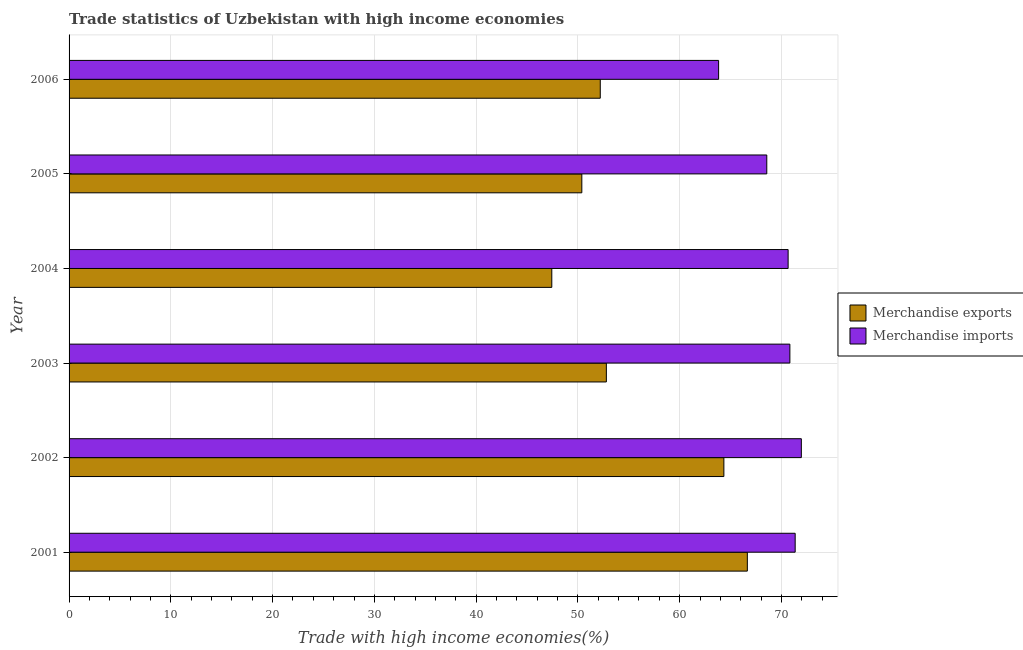Are the number of bars on each tick of the Y-axis equal?
Offer a terse response. Yes. How many bars are there on the 4th tick from the top?
Your answer should be very brief. 2. What is the label of the 1st group of bars from the top?
Your response must be concise. 2006. In how many cases, is the number of bars for a given year not equal to the number of legend labels?
Provide a succinct answer. 0. What is the merchandise exports in 2001?
Keep it short and to the point. 66.65. Across all years, what is the maximum merchandise imports?
Your answer should be very brief. 71.96. Across all years, what is the minimum merchandise exports?
Provide a short and direct response. 47.44. In which year was the merchandise exports minimum?
Your response must be concise. 2004. What is the total merchandise imports in the graph?
Give a very brief answer. 417.2. What is the difference between the merchandise imports in 2004 and that in 2006?
Your answer should be very brief. 6.83. What is the difference between the merchandise imports in 2002 and the merchandise exports in 2004?
Provide a short and direct response. 24.52. What is the average merchandise imports per year?
Ensure brevity in your answer.  69.53. In the year 2006, what is the difference between the merchandise imports and merchandise exports?
Your answer should be compact. 11.63. In how many years, is the merchandise imports greater than 72 %?
Give a very brief answer. 0. What is the ratio of the merchandise imports in 2002 to that in 2004?
Ensure brevity in your answer.  1.02. Is the difference between the merchandise imports in 2005 and 2006 greater than the difference between the merchandise exports in 2005 and 2006?
Your answer should be very brief. Yes. What is the difference between the highest and the second highest merchandise imports?
Make the answer very short. 0.61. What is the difference between the highest and the lowest merchandise imports?
Offer a terse response. 8.13. In how many years, is the merchandise exports greater than the average merchandise exports taken over all years?
Your response must be concise. 2. Is the sum of the merchandise imports in 2002 and 2005 greater than the maximum merchandise exports across all years?
Offer a very short reply. Yes. What does the 1st bar from the top in 2002 represents?
Offer a terse response. Merchandise imports. What does the 1st bar from the bottom in 2004 represents?
Your answer should be very brief. Merchandise exports. Are all the bars in the graph horizontal?
Give a very brief answer. Yes. What is the difference between two consecutive major ticks on the X-axis?
Provide a short and direct response. 10. Does the graph contain any zero values?
Your response must be concise. No. Does the graph contain grids?
Provide a short and direct response. Yes. How are the legend labels stacked?
Your answer should be very brief. Vertical. What is the title of the graph?
Offer a very short reply. Trade statistics of Uzbekistan with high income economies. Does "Constant 2005 US$" appear as one of the legend labels in the graph?
Provide a short and direct response. No. What is the label or title of the X-axis?
Provide a short and direct response. Trade with high income economies(%). What is the Trade with high income economies(%) of Merchandise exports in 2001?
Your response must be concise. 66.65. What is the Trade with high income economies(%) in Merchandise imports in 2001?
Keep it short and to the point. 71.35. What is the Trade with high income economies(%) in Merchandise exports in 2002?
Offer a very short reply. 64.35. What is the Trade with high income economies(%) in Merchandise imports in 2002?
Give a very brief answer. 71.96. What is the Trade with high income economies(%) in Merchandise exports in 2003?
Your answer should be very brief. 52.8. What is the Trade with high income economies(%) of Merchandise imports in 2003?
Provide a succinct answer. 70.83. What is the Trade with high income economies(%) in Merchandise exports in 2004?
Offer a very short reply. 47.44. What is the Trade with high income economies(%) of Merchandise imports in 2004?
Ensure brevity in your answer.  70.66. What is the Trade with high income economies(%) in Merchandise exports in 2005?
Offer a terse response. 50.39. What is the Trade with high income economies(%) in Merchandise imports in 2005?
Give a very brief answer. 68.56. What is the Trade with high income economies(%) of Merchandise exports in 2006?
Provide a succinct answer. 52.2. What is the Trade with high income economies(%) in Merchandise imports in 2006?
Ensure brevity in your answer.  63.83. Across all years, what is the maximum Trade with high income economies(%) of Merchandise exports?
Your answer should be very brief. 66.65. Across all years, what is the maximum Trade with high income economies(%) in Merchandise imports?
Your answer should be compact. 71.96. Across all years, what is the minimum Trade with high income economies(%) of Merchandise exports?
Your answer should be very brief. 47.44. Across all years, what is the minimum Trade with high income economies(%) in Merchandise imports?
Your response must be concise. 63.83. What is the total Trade with high income economies(%) of Merchandise exports in the graph?
Offer a terse response. 333.82. What is the total Trade with high income economies(%) in Merchandise imports in the graph?
Ensure brevity in your answer.  417.2. What is the difference between the Trade with high income economies(%) in Merchandise exports in 2001 and that in 2002?
Your answer should be compact. 2.31. What is the difference between the Trade with high income economies(%) of Merchandise imports in 2001 and that in 2002?
Make the answer very short. -0.61. What is the difference between the Trade with high income economies(%) of Merchandise exports in 2001 and that in 2003?
Your answer should be compact. 13.85. What is the difference between the Trade with high income economies(%) in Merchandise imports in 2001 and that in 2003?
Your answer should be very brief. 0.52. What is the difference between the Trade with high income economies(%) of Merchandise exports in 2001 and that in 2004?
Your answer should be compact. 19.22. What is the difference between the Trade with high income economies(%) of Merchandise imports in 2001 and that in 2004?
Ensure brevity in your answer.  0.69. What is the difference between the Trade with high income economies(%) in Merchandise exports in 2001 and that in 2005?
Your answer should be very brief. 16.27. What is the difference between the Trade with high income economies(%) in Merchandise imports in 2001 and that in 2005?
Keep it short and to the point. 2.79. What is the difference between the Trade with high income economies(%) of Merchandise exports in 2001 and that in 2006?
Your answer should be compact. 14.45. What is the difference between the Trade with high income economies(%) in Merchandise imports in 2001 and that in 2006?
Offer a very short reply. 7.52. What is the difference between the Trade with high income economies(%) of Merchandise exports in 2002 and that in 2003?
Keep it short and to the point. 11.55. What is the difference between the Trade with high income economies(%) in Merchandise imports in 2002 and that in 2003?
Keep it short and to the point. 1.13. What is the difference between the Trade with high income economies(%) in Merchandise exports in 2002 and that in 2004?
Provide a short and direct response. 16.91. What is the difference between the Trade with high income economies(%) in Merchandise imports in 2002 and that in 2004?
Provide a succinct answer. 1.3. What is the difference between the Trade with high income economies(%) of Merchandise exports in 2002 and that in 2005?
Offer a very short reply. 13.96. What is the difference between the Trade with high income economies(%) in Merchandise imports in 2002 and that in 2005?
Your response must be concise. 3.4. What is the difference between the Trade with high income economies(%) in Merchandise exports in 2002 and that in 2006?
Ensure brevity in your answer.  12.15. What is the difference between the Trade with high income economies(%) in Merchandise imports in 2002 and that in 2006?
Offer a very short reply. 8.13. What is the difference between the Trade with high income economies(%) in Merchandise exports in 2003 and that in 2004?
Offer a very short reply. 5.36. What is the difference between the Trade with high income economies(%) of Merchandise imports in 2003 and that in 2004?
Your response must be concise. 0.17. What is the difference between the Trade with high income economies(%) in Merchandise exports in 2003 and that in 2005?
Provide a short and direct response. 2.41. What is the difference between the Trade with high income economies(%) in Merchandise imports in 2003 and that in 2005?
Keep it short and to the point. 2.27. What is the difference between the Trade with high income economies(%) in Merchandise exports in 2003 and that in 2006?
Offer a terse response. 0.6. What is the difference between the Trade with high income economies(%) in Merchandise imports in 2003 and that in 2006?
Offer a terse response. 7. What is the difference between the Trade with high income economies(%) in Merchandise exports in 2004 and that in 2005?
Your answer should be very brief. -2.95. What is the difference between the Trade with high income economies(%) in Merchandise imports in 2004 and that in 2005?
Provide a short and direct response. 2.1. What is the difference between the Trade with high income economies(%) in Merchandise exports in 2004 and that in 2006?
Ensure brevity in your answer.  -4.76. What is the difference between the Trade with high income economies(%) of Merchandise imports in 2004 and that in 2006?
Ensure brevity in your answer.  6.83. What is the difference between the Trade with high income economies(%) in Merchandise exports in 2005 and that in 2006?
Ensure brevity in your answer.  -1.81. What is the difference between the Trade with high income economies(%) of Merchandise imports in 2005 and that in 2006?
Your answer should be very brief. 4.73. What is the difference between the Trade with high income economies(%) of Merchandise exports in 2001 and the Trade with high income economies(%) of Merchandise imports in 2002?
Provide a succinct answer. -5.31. What is the difference between the Trade with high income economies(%) in Merchandise exports in 2001 and the Trade with high income economies(%) in Merchandise imports in 2003?
Keep it short and to the point. -4.18. What is the difference between the Trade with high income economies(%) in Merchandise exports in 2001 and the Trade with high income economies(%) in Merchandise imports in 2004?
Your answer should be very brief. -4.01. What is the difference between the Trade with high income economies(%) in Merchandise exports in 2001 and the Trade with high income economies(%) in Merchandise imports in 2005?
Make the answer very short. -1.91. What is the difference between the Trade with high income economies(%) of Merchandise exports in 2001 and the Trade with high income economies(%) of Merchandise imports in 2006?
Your response must be concise. 2.82. What is the difference between the Trade with high income economies(%) in Merchandise exports in 2002 and the Trade with high income economies(%) in Merchandise imports in 2003?
Your answer should be compact. -6.49. What is the difference between the Trade with high income economies(%) in Merchandise exports in 2002 and the Trade with high income economies(%) in Merchandise imports in 2004?
Provide a succinct answer. -6.31. What is the difference between the Trade with high income economies(%) of Merchandise exports in 2002 and the Trade with high income economies(%) of Merchandise imports in 2005?
Your response must be concise. -4.22. What is the difference between the Trade with high income economies(%) in Merchandise exports in 2002 and the Trade with high income economies(%) in Merchandise imports in 2006?
Provide a succinct answer. 0.52. What is the difference between the Trade with high income economies(%) of Merchandise exports in 2003 and the Trade with high income economies(%) of Merchandise imports in 2004?
Give a very brief answer. -17.86. What is the difference between the Trade with high income economies(%) in Merchandise exports in 2003 and the Trade with high income economies(%) in Merchandise imports in 2005?
Offer a terse response. -15.77. What is the difference between the Trade with high income economies(%) of Merchandise exports in 2003 and the Trade with high income economies(%) of Merchandise imports in 2006?
Keep it short and to the point. -11.03. What is the difference between the Trade with high income economies(%) in Merchandise exports in 2004 and the Trade with high income economies(%) in Merchandise imports in 2005?
Offer a very short reply. -21.13. What is the difference between the Trade with high income economies(%) of Merchandise exports in 2004 and the Trade with high income economies(%) of Merchandise imports in 2006?
Your answer should be very brief. -16.39. What is the difference between the Trade with high income economies(%) in Merchandise exports in 2005 and the Trade with high income economies(%) in Merchandise imports in 2006?
Keep it short and to the point. -13.44. What is the average Trade with high income economies(%) of Merchandise exports per year?
Provide a succinct answer. 55.64. What is the average Trade with high income economies(%) of Merchandise imports per year?
Make the answer very short. 69.53. In the year 2001, what is the difference between the Trade with high income economies(%) of Merchandise exports and Trade with high income economies(%) of Merchandise imports?
Your answer should be very brief. -4.7. In the year 2002, what is the difference between the Trade with high income economies(%) of Merchandise exports and Trade with high income economies(%) of Merchandise imports?
Provide a succinct answer. -7.61. In the year 2003, what is the difference between the Trade with high income economies(%) of Merchandise exports and Trade with high income economies(%) of Merchandise imports?
Your answer should be very brief. -18.03. In the year 2004, what is the difference between the Trade with high income economies(%) in Merchandise exports and Trade with high income economies(%) in Merchandise imports?
Provide a short and direct response. -23.22. In the year 2005, what is the difference between the Trade with high income economies(%) in Merchandise exports and Trade with high income economies(%) in Merchandise imports?
Ensure brevity in your answer.  -18.18. In the year 2006, what is the difference between the Trade with high income economies(%) of Merchandise exports and Trade with high income economies(%) of Merchandise imports?
Your answer should be very brief. -11.63. What is the ratio of the Trade with high income economies(%) in Merchandise exports in 2001 to that in 2002?
Offer a terse response. 1.04. What is the ratio of the Trade with high income economies(%) in Merchandise imports in 2001 to that in 2002?
Your answer should be very brief. 0.99. What is the ratio of the Trade with high income economies(%) of Merchandise exports in 2001 to that in 2003?
Provide a succinct answer. 1.26. What is the ratio of the Trade with high income economies(%) in Merchandise imports in 2001 to that in 2003?
Ensure brevity in your answer.  1.01. What is the ratio of the Trade with high income economies(%) of Merchandise exports in 2001 to that in 2004?
Make the answer very short. 1.41. What is the ratio of the Trade with high income economies(%) in Merchandise imports in 2001 to that in 2004?
Offer a very short reply. 1.01. What is the ratio of the Trade with high income economies(%) of Merchandise exports in 2001 to that in 2005?
Your response must be concise. 1.32. What is the ratio of the Trade with high income economies(%) of Merchandise imports in 2001 to that in 2005?
Offer a terse response. 1.04. What is the ratio of the Trade with high income economies(%) in Merchandise exports in 2001 to that in 2006?
Make the answer very short. 1.28. What is the ratio of the Trade with high income economies(%) in Merchandise imports in 2001 to that in 2006?
Provide a short and direct response. 1.12. What is the ratio of the Trade with high income economies(%) in Merchandise exports in 2002 to that in 2003?
Make the answer very short. 1.22. What is the ratio of the Trade with high income economies(%) in Merchandise imports in 2002 to that in 2003?
Provide a succinct answer. 1.02. What is the ratio of the Trade with high income economies(%) of Merchandise exports in 2002 to that in 2004?
Offer a very short reply. 1.36. What is the ratio of the Trade with high income economies(%) in Merchandise imports in 2002 to that in 2004?
Provide a short and direct response. 1.02. What is the ratio of the Trade with high income economies(%) of Merchandise exports in 2002 to that in 2005?
Your answer should be very brief. 1.28. What is the ratio of the Trade with high income economies(%) in Merchandise imports in 2002 to that in 2005?
Ensure brevity in your answer.  1.05. What is the ratio of the Trade with high income economies(%) of Merchandise exports in 2002 to that in 2006?
Make the answer very short. 1.23. What is the ratio of the Trade with high income economies(%) of Merchandise imports in 2002 to that in 2006?
Keep it short and to the point. 1.13. What is the ratio of the Trade with high income economies(%) of Merchandise exports in 2003 to that in 2004?
Provide a succinct answer. 1.11. What is the ratio of the Trade with high income economies(%) of Merchandise imports in 2003 to that in 2004?
Provide a short and direct response. 1. What is the ratio of the Trade with high income economies(%) in Merchandise exports in 2003 to that in 2005?
Your answer should be compact. 1.05. What is the ratio of the Trade with high income economies(%) in Merchandise imports in 2003 to that in 2005?
Give a very brief answer. 1.03. What is the ratio of the Trade with high income economies(%) of Merchandise exports in 2003 to that in 2006?
Offer a very short reply. 1.01. What is the ratio of the Trade with high income economies(%) of Merchandise imports in 2003 to that in 2006?
Offer a very short reply. 1.11. What is the ratio of the Trade with high income economies(%) of Merchandise exports in 2004 to that in 2005?
Keep it short and to the point. 0.94. What is the ratio of the Trade with high income economies(%) of Merchandise imports in 2004 to that in 2005?
Your response must be concise. 1.03. What is the ratio of the Trade with high income economies(%) in Merchandise exports in 2004 to that in 2006?
Make the answer very short. 0.91. What is the ratio of the Trade with high income economies(%) of Merchandise imports in 2004 to that in 2006?
Provide a short and direct response. 1.11. What is the ratio of the Trade with high income economies(%) in Merchandise exports in 2005 to that in 2006?
Offer a terse response. 0.97. What is the ratio of the Trade with high income economies(%) of Merchandise imports in 2005 to that in 2006?
Make the answer very short. 1.07. What is the difference between the highest and the second highest Trade with high income economies(%) in Merchandise exports?
Give a very brief answer. 2.31. What is the difference between the highest and the second highest Trade with high income economies(%) in Merchandise imports?
Make the answer very short. 0.61. What is the difference between the highest and the lowest Trade with high income economies(%) of Merchandise exports?
Provide a succinct answer. 19.22. What is the difference between the highest and the lowest Trade with high income economies(%) of Merchandise imports?
Provide a succinct answer. 8.13. 